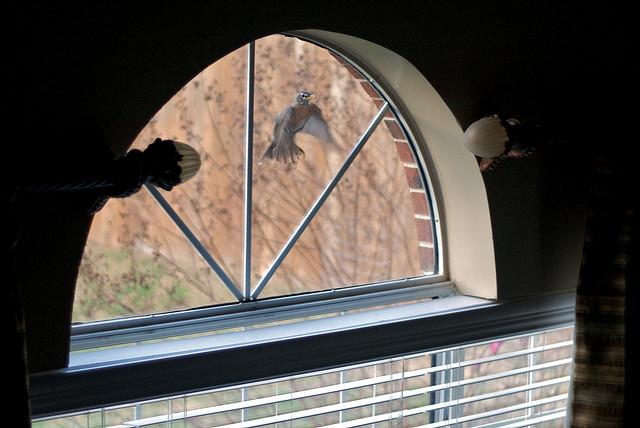What kind of window is in the photo?
Give a very brief answer. Half circle. Did the bird fly into the window?
Quick response, please. Yes. Is this bird looking in?
Give a very brief answer. Yes. 